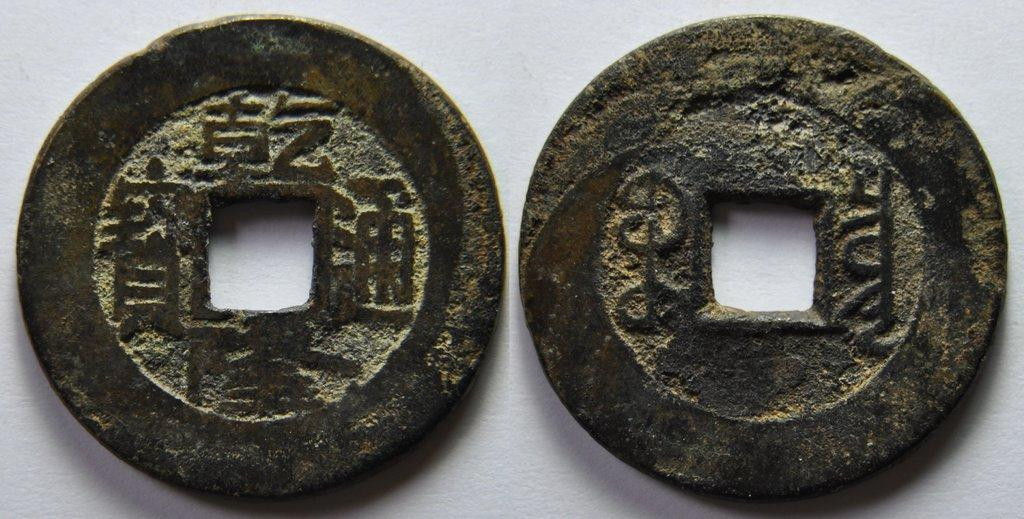How many coins are visible in the image? There are two coins in the image. Where are the coins located in the image? The coins are on a surface in the image. What type of heart can be seen beating in the image? There is no heart visible in the image; it only contains two coins on a surface. 